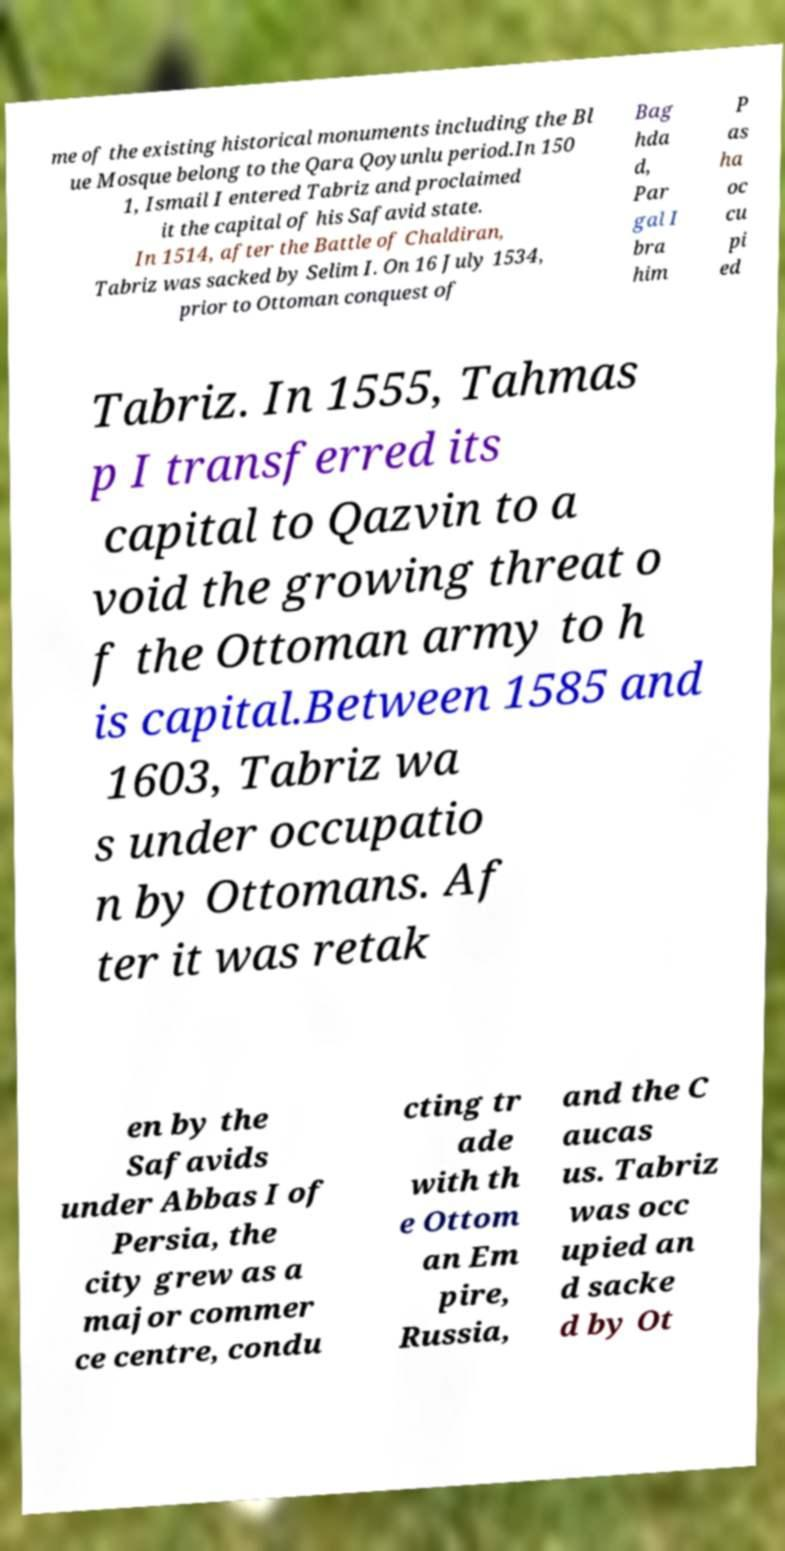Can you read and provide the text displayed in the image?This photo seems to have some interesting text. Can you extract and type it out for me? me of the existing historical monuments including the Bl ue Mosque belong to the Qara Qoyunlu period.In 150 1, Ismail I entered Tabriz and proclaimed it the capital of his Safavid state. In 1514, after the Battle of Chaldiran, Tabriz was sacked by Selim I. On 16 July 1534, prior to Ottoman conquest of Bag hda d, Par gal I bra him P as ha oc cu pi ed Tabriz. In 1555, Tahmas p I transferred its capital to Qazvin to a void the growing threat o f the Ottoman army to h is capital.Between 1585 and 1603, Tabriz wa s under occupatio n by Ottomans. Af ter it was retak en by the Safavids under Abbas I of Persia, the city grew as a major commer ce centre, condu cting tr ade with th e Ottom an Em pire, Russia, and the C aucas us. Tabriz was occ upied an d sacke d by Ot 